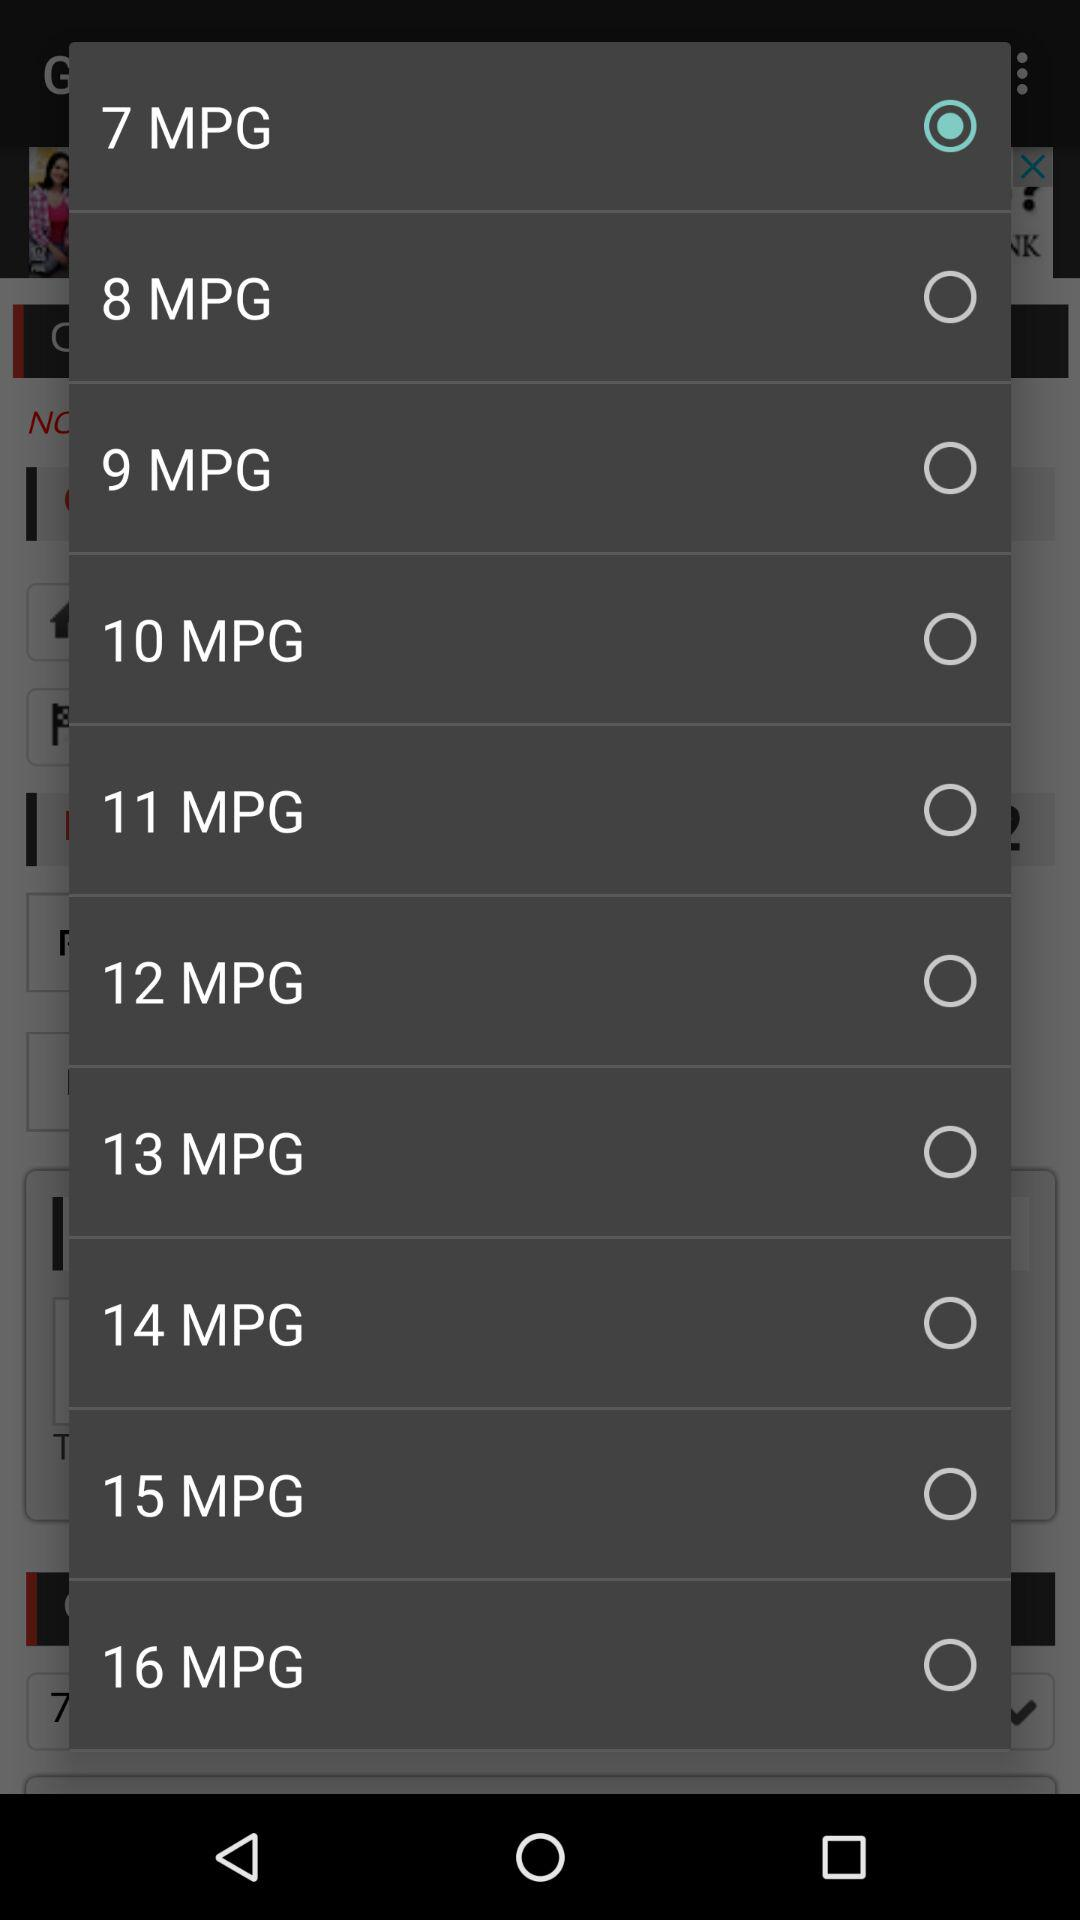What are the available options? The available options are "7 MPG", "8 MPG", "9 MPG", "10 MPG", "11 MPG", "12 MPG", "13 MPG", "14 MPG", "15 MPG" and "16 MPG". 